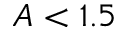Convert formula to latex. <formula><loc_0><loc_0><loc_500><loc_500>A < 1 . 5</formula> 